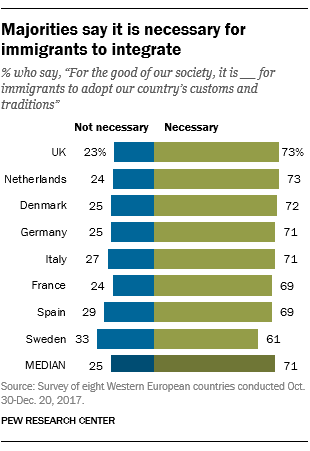List a handful of essential elements in this visual. According to a recent survey, a staggering 73% of people in the UK believe that it is necessary for immigrants to integrate into society. According to a recent survey in France, approximately 0.436111111... people believe that it is necessary for immigrants to integrate into French society. On the other hand, the remaining respondents do not believe that it is necessary for immigrants to integrate. 